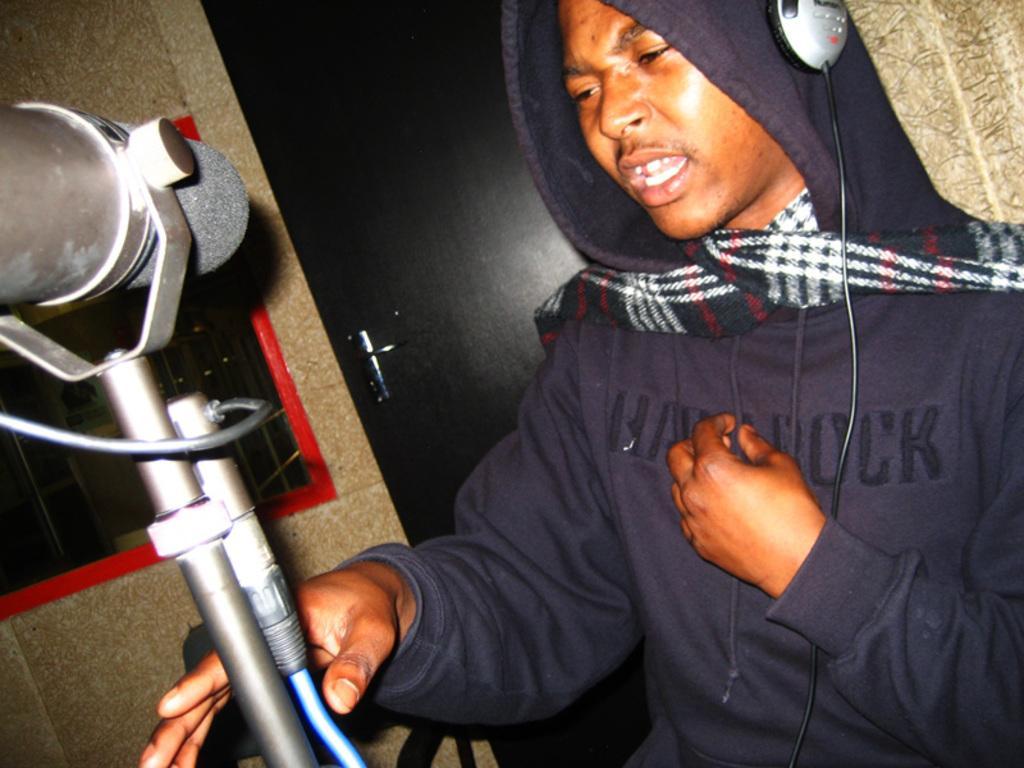Please provide a concise description of this image. On the right side of this image I can see a man wearing a blue color jacket, holding a metal object in the hand and it seems like he is speaking. At the back of this man I can see a wall along with the door and window. 